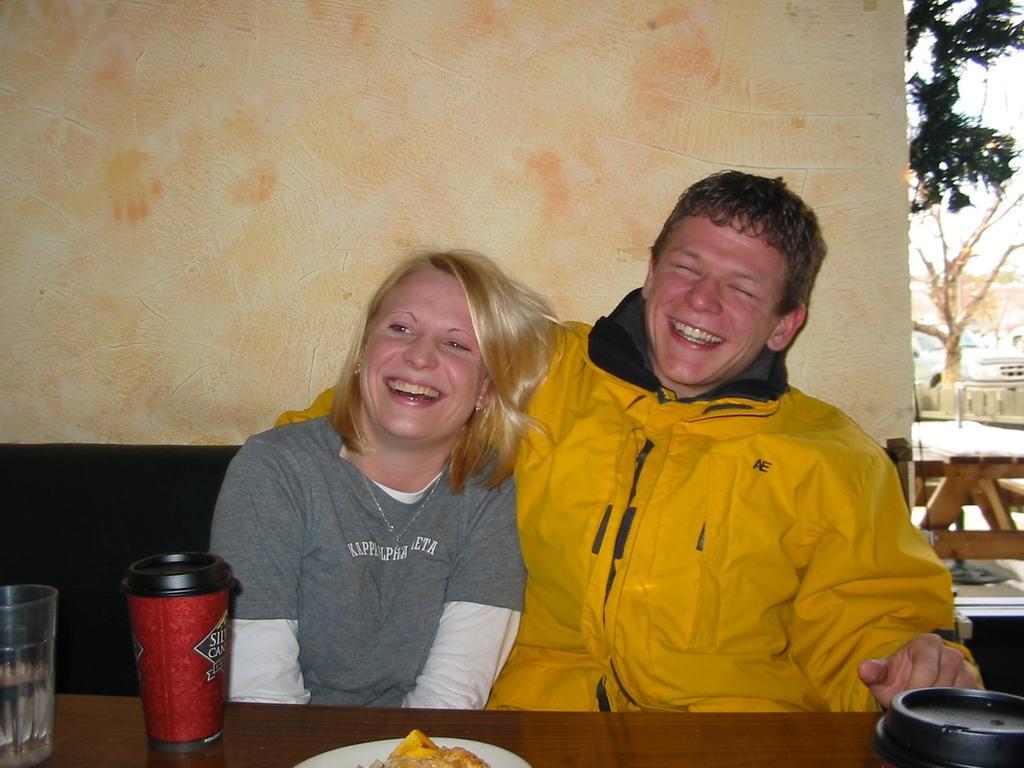Could you give a brief overview of what you see in this image? In this picture, we can see a few people sitting, we can see a table and some objects on table, like glass, food items on a plate, we can see the wall, tree, some wooden object, ground, poles, and a vehicle. 